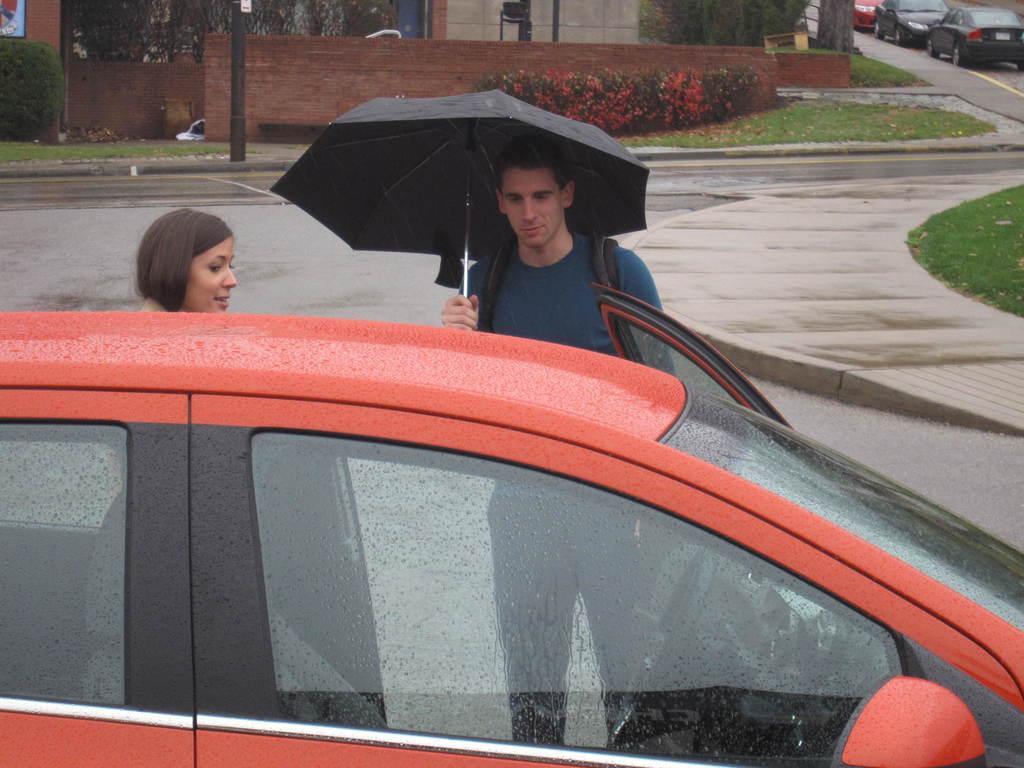Please provide a concise description of this image. In this picture we can see there are two people standing on the road and the man is holding an umbrella. In front of the people there is a car. Behind the people there is a pole, plants and a wall. Behind the wall, it looks like a building. On the right side of the building there are some vehicles parked on the road. 